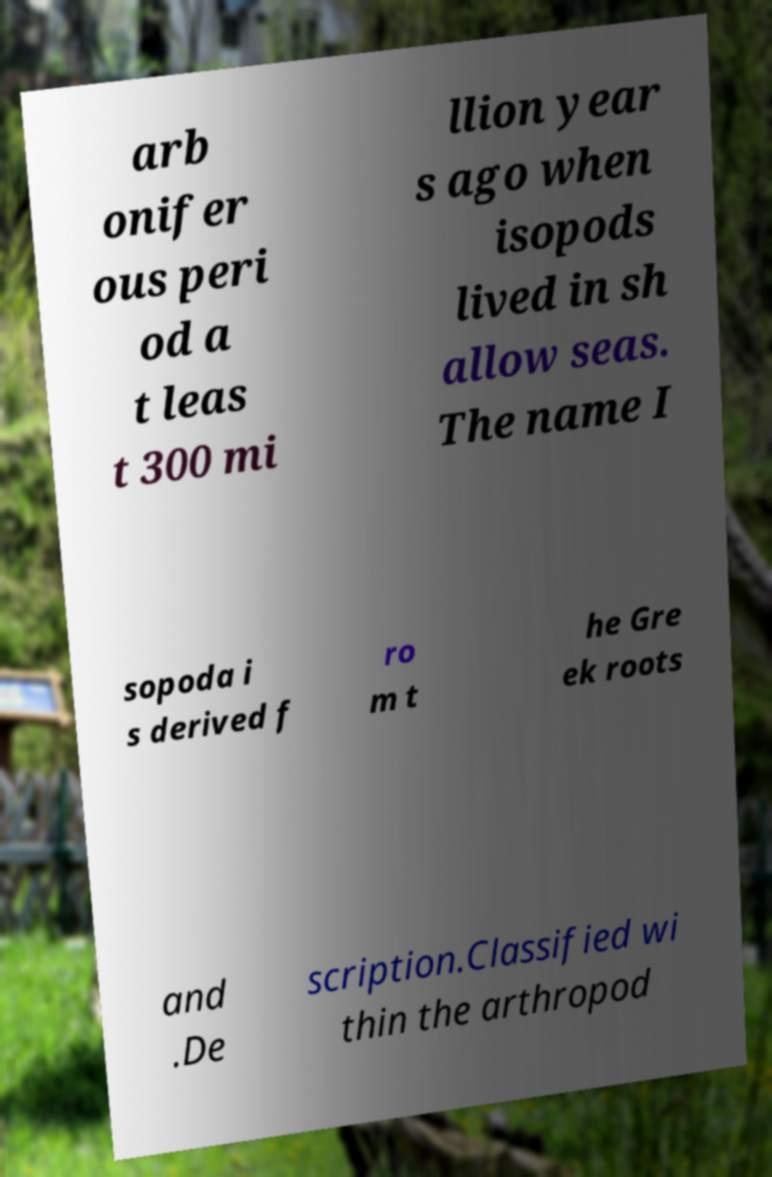Can you accurately transcribe the text from the provided image for me? arb onifer ous peri od a t leas t 300 mi llion year s ago when isopods lived in sh allow seas. The name I sopoda i s derived f ro m t he Gre ek roots and .De scription.Classified wi thin the arthropod 